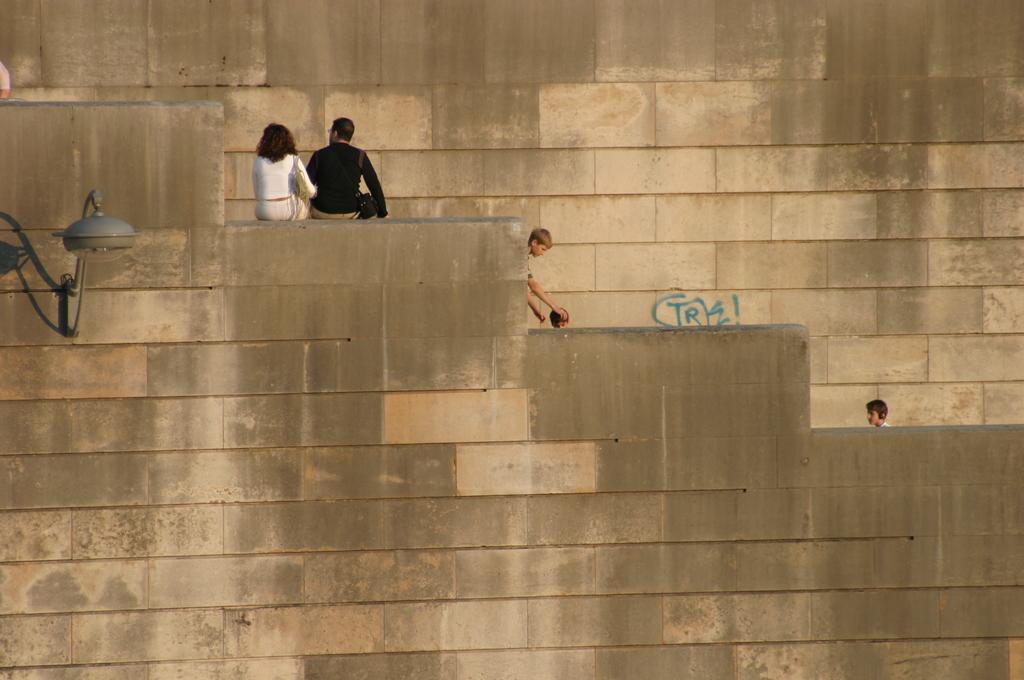How would you summarize this image in a sentence or two? On the top left, there is a woman and a man sitting on a wall. Beside them, there are two children. On the right side, there is another child. In the background, there is a brick wall. 